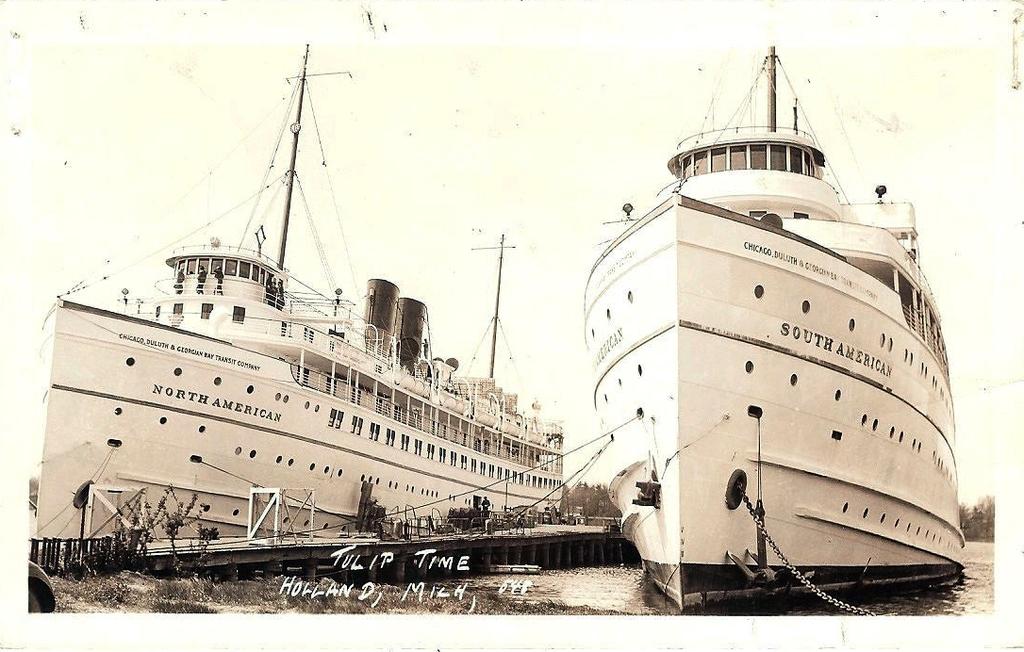What is the name of the ship on the left?
Keep it short and to the point. North american. 